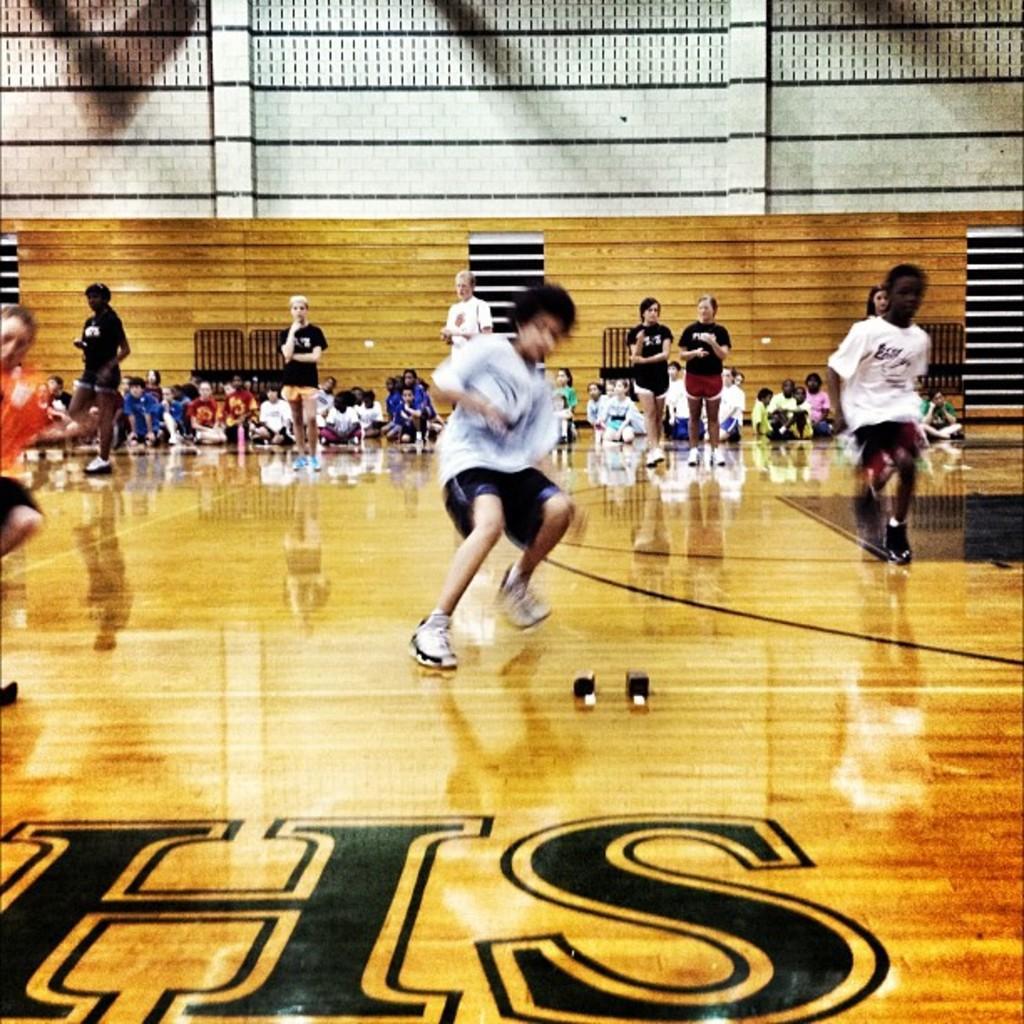In one or two sentences, can you explain what this image depicts? In this image I can see a wooden floor , on the floor I can see crowd of people and wooden wall visible in the middle and there is a text visible on the bottom in the floor. 